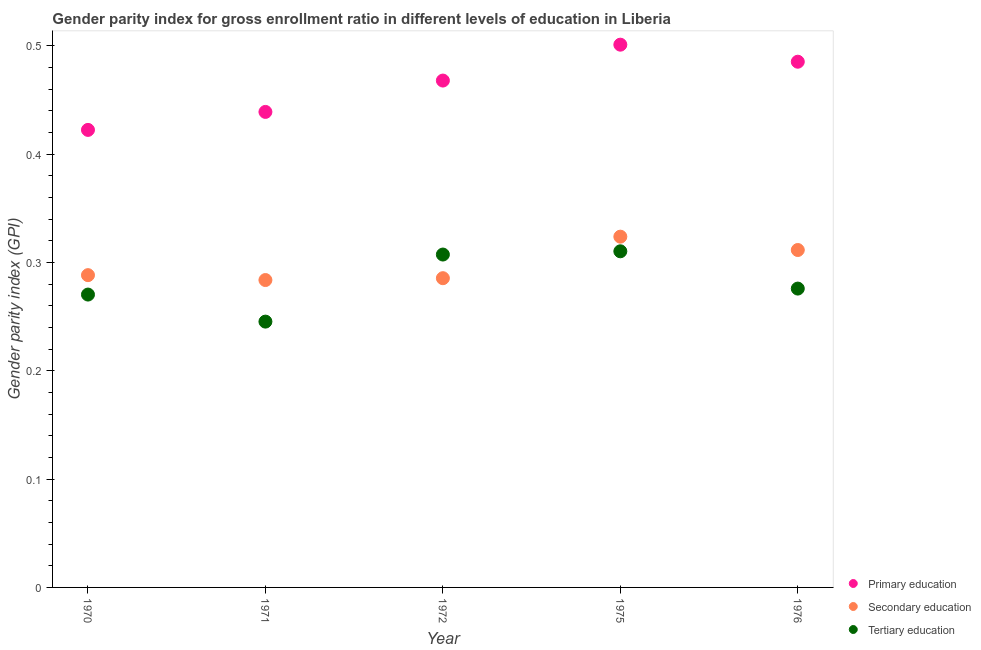How many different coloured dotlines are there?
Give a very brief answer. 3. What is the gender parity index in secondary education in 1971?
Your answer should be compact. 0.28. Across all years, what is the maximum gender parity index in tertiary education?
Make the answer very short. 0.31. Across all years, what is the minimum gender parity index in tertiary education?
Your response must be concise. 0.25. In which year was the gender parity index in primary education maximum?
Offer a terse response. 1975. What is the total gender parity index in secondary education in the graph?
Your answer should be very brief. 1.49. What is the difference between the gender parity index in primary education in 1970 and that in 1972?
Ensure brevity in your answer.  -0.05. What is the difference between the gender parity index in primary education in 1976 and the gender parity index in secondary education in 1970?
Ensure brevity in your answer.  0.2. What is the average gender parity index in primary education per year?
Your answer should be compact. 0.46. In the year 1976, what is the difference between the gender parity index in primary education and gender parity index in tertiary education?
Provide a succinct answer. 0.21. What is the ratio of the gender parity index in secondary education in 1971 to that in 1976?
Keep it short and to the point. 0.91. Is the gender parity index in tertiary education in 1972 less than that in 1976?
Your response must be concise. No. What is the difference between the highest and the second highest gender parity index in tertiary education?
Make the answer very short. 0. What is the difference between the highest and the lowest gender parity index in primary education?
Make the answer very short. 0.08. Is the sum of the gender parity index in tertiary education in 1970 and 1972 greater than the maximum gender parity index in secondary education across all years?
Offer a very short reply. Yes. Is it the case that in every year, the sum of the gender parity index in primary education and gender parity index in secondary education is greater than the gender parity index in tertiary education?
Your answer should be very brief. Yes. How many dotlines are there?
Give a very brief answer. 3. What is the difference between two consecutive major ticks on the Y-axis?
Offer a terse response. 0.1. How are the legend labels stacked?
Give a very brief answer. Vertical. What is the title of the graph?
Offer a terse response. Gender parity index for gross enrollment ratio in different levels of education in Liberia. Does "Machinery" appear as one of the legend labels in the graph?
Offer a terse response. No. What is the label or title of the X-axis?
Provide a short and direct response. Year. What is the label or title of the Y-axis?
Your answer should be very brief. Gender parity index (GPI). What is the Gender parity index (GPI) of Primary education in 1970?
Keep it short and to the point. 0.42. What is the Gender parity index (GPI) of Secondary education in 1970?
Your answer should be compact. 0.29. What is the Gender parity index (GPI) in Tertiary education in 1970?
Ensure brevity in your answer.  0.27. What is the Gender parity index (GPI) of Primary education in 1971?
Your answer should be very brief. 0.44. What is the Gender parity index (GPI) of Secondary education in 1971?
Your response must be concise. 0.28. What is the Gender parity index (GPI) of Tertiary education in 1971?
Ensure brevity in your answer.  0.25. What is the Gender parity index (GPI) of Primary education in 1972?
Your response must be concise. 0.47. What is the Gender parity index (GPI) in Secondary education in 1972?
Your answer should be compact. 0.29. What is the Gender parity index (GPI) of Tertiary education in 1972?
Provide a short and direct response. 0.31. What is the Gender parity index (GPI) in Primary education in 1975?
Offer a very short reply. 0.5. What is the Gender parity index (GPI) in Secondary education in 1975?
Provide a short and direct response. 0.32. What is the Gender parity index (GPI) in Tertiary education in 1975?
Your answer should be compact. 0.31. What is the Gender parity index (GPI) of Primary education in 1976?
Make the answer very short. 0.49. What is the Gender parity index (GPI) in Secondary education in 1976?
Provide a short and direct response. 0.31. What is the Gender parity index (GPI) of Tertiary education in 1976?
Ensure brevity in your answer.  0.28. Across all years, what is the maximum Gender parity index (GPI) in Primary education?
Keep it short and to the point. 0.5. Across all years, what is the maximum Gender parity index (GPI) of Secondary education?
Offer a terse response. 0.32. Across all years, what is the maximum Gender parity index (GPI) of Tertiary education?
Make the answer very short. 0.31. Across all years, what is the minimum Gender parity index (GPI) in Primary education?
Ensure brevity in your answer.  0.42. Across all years, what is the minimum Gender parity index (GPI) of Secondary education?
Provide a short and direct response. 0.28. Across all years, what is the minimum Gender parity index (GPI) in Tertiary education?
Keep it short and to the point. 0.25. What is the total Gender parity index (GPI) of Primary education in the graph?
Provide a short and direct response. 2.32. What is the total Gender parity index (GPI) of Secondary education in the graph?
Your answer should be very brief. 1.49. What is the total Gender parity index (GPI) of Tertiary education in the graph?
Make the answer very short. 1.41. What is the difference between the Gender parity index (GPI) of Primary education in 1970 and that in 1971?
Offer a terse response. -0.02. What is the difference between the Gender parity index (GPI) of Secondary education in 1970 and that in 1971?
Offer a terse response. 0. What is the difference between the Gender parity index (GPI) in Tertiary education in 1970 and that in 1971?
Offer a very short reply. 0.03. What is the difference between the Gender parity index (GPI) of Primary education in 1970 and that in 1972?
Offer a terse response. -0.05. What is the difference between the Gender parity index (GPI) in Secondary education in 1970 and that in 1972?
Provide a succinct answer. 0. What is the difference between the Gender parity index (GPI) in Tertiary education in 1970 and that in 1972?
Ensure brevity in your answer.  -0.04. What is the difference between the Gender parity index (GPI) in Primary education in 1970 and that in 1975?
Provide a succinct answer. -0.08. What is the difference between the Gender parity index (GPI) of Secondary education in 1970 and that in 1975?
Give a very brief answer. -0.04. What is the difference between the Gender parity index (GPI) in Tertiary education in 1970 and that in 1975?
Offer a terse response. -0.04. What is the difference between the Gender parity index (GPI) in Primary education in 1970 and that in 1976?
Your answer should be very brief. -0.06. What is the difference between the Gender parity index (GPI) in Secondary education in 1970 and that in 1976?
Offer a terse response. -0.02. What is the difference between the Gender parity index (GPI) of Tertiary education in 1970 and that in 1976?
Keep it short and to the point. -0.01. What is the difference between the Gender parity index (GPI) in Primary education in 1971 and that in 1972?
Keep it short and to the point. -0.03. What is the difference between the Gender parity index (GPI) of Secondary education in 1971 and that in 1972?
Ensure brevity in your answer.  -0. What is the difference between the Gender parity index (GPI) of Tertiary education in 1971 and that in 1972?
Offer a very short reply. -0.06. What is the difference between the Gender parity index (GPI) in Primary education in 1971 and that in 1975?
Your answer should be very brief. -0.06. What is the difference between the Gender parity index (GPI) in Secondary education in 1971 and that in 1975?
Your answer should be compact. -0.04. What is the difference between the Gender parity index (GPI) of Tertiary education in 1971 and that in 1975?
Keep it short and to the point. -0.06. What is the difference between the Gender parity index (GPI) of Primary education in 1971 and that in 1976?
Offer a terse response. -0.05. What is the difference between the Gender parity index (GPI) of Secondary education in 1971 and that in 1976?
Ensure brevity in your answer.  -0.03. What is the difference between the Gender parity index (GPI) in Tertiary education in 1971 and that in 1976?
Provide a short and direct response. -0.03. What is the difference between the Gender parity index (GPI) in Primary education in 1972 and that in 1975?
Your answer should be very brief. -0.03. What is the difference between the Gender parity index (GPI) in Secondary education in 1972 and that in 1975?
Offer a very short reply. -0.04. What is the difference between the Gender parity index (GPI) of Tertiary education in 1972 and that in 1975?
Your answer should be compact. -0. What is the difference between the Gender parity index (GPI) in Primary education in 1972 and that in 1976?
Offer a terse response. -0.02. What is the difference between the Gender parity index (GPI) in Secondary education in 1972 and that in 1976?
Offer a terse response. -0.03. What is the difference between the Gender parity index (GPI) of Tertiary education in 1972 and that in 1976?
Give a very brief answer. 0.03. What is the difference between the Gender parity index (GPI) in Primary education in 1975 and that in 1976?
Offer a terse response. 0.02. What is the difference between the Gender parity index (GPI) in Secondary education in 1975 and that in 1976?
Your answer should be very brief. 0.01. What is the difference between the Gender parity index (GPI) in Tertiary education in 1975 and that in 1976?
Your answer should be very brief. 0.03. What is the difference between the Gender parity index (GPI) of Primary education in 1970 and the Gender parity index (GPI) of Secondary education in 1971?
Your answer should be compact. 0.14. What is the difference between the Gender parity index (GPI) in Primary education in 1970 and the Gender parity index (GPI) in Tertiary education in 1971?
Your answer should be very brief. 0.18. What is the difference between the Gender parity index (GPI) in Secondary education in 1970 and the Gender parity index (GPI) in Tertiary education in 1971?
Offer a terse response. 0.04. What is the difference between the Gender parity index (GPI) of Primary education in 1970 and the Gender parity index (GPI) of Secondary education in 1972?
Keep it short and to the point. 0.14. What is the difference between the Gender parity index (GPI) in Primary education in 1970 and the Gender parity index (GPI) in Tertiary education in 1972?
Keep it short and to the point. 0.12. What is the difference between the Gender parity index (GPI) in Secondary education in 1970 and the Gender parity index (GPI) in Tertiary education in 1972?
Ensure brevity in your answer.  -0.02. What is the difference between the Gender parity index (GPI) in Primary education in 1970 and the Gender parity index (GPI) in Secondary education in 1975?
Keep it short and to the point. 0.1. What is the difference between the Gender parity index (GPI) in Primary education in 1970 and the Gender parity index (GPI) in Tertiary education in 1975?
Provide a succinct answer. 0.11. What is the difference between the Gender parity index (GPI) of Secondary education in 1970 and the Gender parity index (GPI) of Tertiary education in 1975?
Offer a terse response. -0.02. What is the difference between the Gender parity index (GPI) of Primary education in 1970 and the Gender parity index (GPI) of Secondary education in 1976?
Offer a very short reply. 0.11. What is the difference between the Gender parity index (GPI) of Primary education in 1970 and the Gender parity index (GPI) of Tertiary education in 1976?
Ensure brevity in your answer.  0.15. What is the difference between the Gender parity index (GPI) in Secondary education in 1970 and the Gender parity index (GPI) in Tertiary education in 1976?
Keep it short and to the point. 0.01. What is the difference between the Gender parity index (GPI) of Primary education in 1971 and the Gender parity index (GPI) of Secondary education in 1972?
Offer a very short reply. 0.15. What is the difference between the Gender parity index (GPI) of Primary education in 1971 and the Gender parity index (GPI) of Tertiary education in 1972?
Offer a very short reply. 0.13. What is the difference between the Gender parity index (GPI) in Secondary education in 1971 and the Gender parity index (GPI) in Tertiary education in 1972?
Make the answer very short. -0.02. What is the difference between the Gender parity index (GPI) in Primary education in 1971 and the Gender parity index (GPI) in Secondary education in 1975?
Offer a terse response. 0.12. What is the difference between the Gender parity index (GPI) of Primary education in 1971 and the Gender parity index (GPI) of Tertiary education in 1975?
Provide a short and direct response. 0.13. What is the difference between the Gender parity index (GPI) in Secondary education in 1971 and the Gender parity index (GPI) in Tertiary education in 1975?
Provide a short and direct response. -0.03. What is the difference between the Gender parity index (GPI) of Primary education in 1971 and the Gender parity index (GPI) of Secondary education in 1976?
Your answer should be compact. 0.13. What is the difference between the Gender parity index (GPI) of Primary education in 1971 and the Gender parity index (GPI) of Tertiary education in 1976?
Offer a terse response. 0.16. What is the difference between the Gender parity index (GPI) of Secondary education in 1971 and the Gender parity index (GPI) of Tertiary education in 1976?
Offer a very short reply. 0.01. What is the difference between the Gender parity index (GPI) of Primary education in 1972 and the Gender parity index (GPI) of Secondary education in 1975?
Keep it short and to the point. 0.14. What is the difference between the Gender parity index (GPI) in Primary education in 1972 and the Gender parity index (GPI) in Tertiary education in 1975?
Your response must be concise. 0.16. What is the difference between the Gender parity index (GPI) of Secondary education in 1972 and the Gender parity index (GPI) of Tertiary education in 1975?
Offer a terse response. -0.02. What is the difference between the Gender parity index (GPI) in Primary education in 1972 and the Gender parity index (GPI) in Secondary education in 1976?
Offer a terse response. 0.16. What is the difference between the Gender parity index (GPI) in Primary education in 1972 and the Gender parity index (GPI) in Tertiary education in 1976?
Offer a very short reply. 0.19. What is the difference between the Gender parity index (GPI) in Secondary education in 1972 and the Gender parity index (GPI) in Tertiary education in 1976?
Keep it short and to the point. 0.01. What is the difference between the Gender parity index (GPI) in Primary education in 1975 and the Gender parity index (GPI) in Secondary education in 1976?
Offer a terse response. 0.19. What is the difference between the Gender parity index (GPI) in Primary education in 1975 and the Gender parity index (GPI) in Tertiary education in 1976?
Provide a succinct answer. 0.23. What is the difference between the Gender parity index (GPI) of Secondary education in 1975 and the Gender parity index (GPI) of Tertiary education in 1976?
Provide a short and direct response. 0.05. What is the average Gender parity index (GPI) of Primary education per year?
Provide a short and direct response. 0.46. What is the average Gender parity index (GPI) in Secondary education per year?
Make the answer very short. 0.3. What is the average Gender parity index (GPI) in Tertiary education per year?
Make the answer very short. 0.28. In the year 1970, what is the difference between the Gender parity index (GPI) in Primary education and Gender parity index (GPI) in Secondary education?
Provide a short and direct response. 0.13. In the year 1970, what is the difference between the Gender parity index (GPI) of Primary education and Gender parity index (GPI) of Tertiary education?
Ensure brevity in your answer.  0.15. In the year 1970, what is the difference between the Gender parity index (GPI) in Secondary education and Gender parity index (GPI) in Tertiary education?
Provide a succinct answer. 0.02. In the year 1971, what is the difference between the Gender parity index (GPI) of Primary education and Gender parity index (GPI) of Secondary education?
Give a very brief answer. 0.16. In the year 1971, what is the difference between the Gender parity index (GPI) of Primary education and Gender parity index (GPI) of Tertiary education?
Keep it short and to the point. 0.19. In the year 1971, what is the difference between the Gender parity index (GPI) in Secondary education and Gender parity index (GPI) in Tertiary education?
Provide a succinct answer. 0.04. In the year 1972, what is the difference between the Gender parity index (GPI) of Primary education and Gender parity index (GPI) of Secondary education?
Ensure brevity in your answer.  0.18. In the year 1972, what is the difference between the Gender parity index (GPI) of Primary education and Gender parity index (GPI) of Tertiary education?
Give a very brief answer. 0.16. In the year 1972, what is the difference between the Gender parity index (GPI) in Secondary education and Gender parity index (GPI) in Tertiary education?
Keep it short and to the point. -0.02. In the year 1975, what is the difference between the Gender parity index (GPI) of Primary education and Gender parity index (GPI) of Secondary education?
Provide a short and direct response. 0.18. In the year 1975, what is the difference between the Gender parity index (GPI) in Primary education and Gender parity index (GPI) in Tertiary education?
Your response must be concise. 0.19. In the year 1975, what is the difference between the Gender parity index (GPI) of Secondary education and Gender parity index (GPI) of Tertiary education?
Keep it short and to the point. 0.01. In the year 1976, what is the difference between the Gender parity index (GPI) in Primary education and Gender parity index (GPI) in Secondary education?
Offer a terse response. 0.17. In the year 1976, what is the difference between the Gender parity index (GPI) of Primary education and Gender parity index (GPI) of Tertiary education?
Offer a terse response. 0.21. In the year 1976, what is the difference between the Gender parity index (GPI) of Secondary education and Gender parity index (GPI) of Tertiary education?
Provide a succinct answer. 0.04. What is the ratio of the Gender parity index (GPI) in Primary education in 1970 to that in 1971?
Make the answer very short. 0.96. What is the ratio of the Gender parity index (GPI) in Secondary education in 1970 to that in 1971?
Offer a very short reply. 1.02. What is the ratio of the Gender parity index (GPI) of Tertiary education in 1970 to that in 1971?
Provide a short and direct response. 1.1. What is the ratio of the Gender parity index (GPI) in Primary education in 1970 to that in 1972?
Your answer should be very brief. 0.9. What is the ratio of the Gender parity index (GPI) in Secondary education in 1970 to that in 1972?
Give a very brief answer. 1.01. What is the ratio of the Gender parity index (GPI) in Tertiary education in 1970 to that in 1972?
Provide a succinct answer. 0.88. What is the ratio of the Gender parity index (GPI) of Primary education in 1970 to that in 1975?
Give a very brief answer. 0.84. What is the ratio of the Gender parity index (GPI) of Secondary education in 1970 to that in 1975?
Offer a very short reply. 0.89. What is the ratio of the Gender parity index (GPI) in Tertiary education in 1970 to that in 1975?
Ensure brevity in your answer.  0.87. What is the ratio of the Gender parity index (GPI) in Primary education in 1970 to that in 1976?
Give a very brief answer. 0.87. What is the ratio of the Gender parity index (GPI) of Secondary education in 1970 to that in 1976?
Keep it short and to the point. 0.93. What is the ratio of the Gender parity index (GPI) in Tertiary education in 1970 to that in 1976?
Provide a short and direct response. 0.98. What is the ratio of the Gender parity index (GPI) in Primary education in 1971 to that in 1972?
Offer a very short reply. 0.94. What is the ratio of the Gender parity index (GPI) in Tertiary education in 1971 to that in 1972?
Provide a succinct answer. 0.8. What is the ratio of the Gender parity index (GPI) in Primary education in 1971 to that in 1975?
Ensure brevity in your answer.  0.88. What is the ratio of the Gender parity index (GPI) of Secondary education in 1971 to that in 1975?
Offer a very short reply. 0.88. What is the ratio of the Gender parity index (GPI) of Tertiary education in 1971 to that in 1975?
Offer a terse response. 0.79. What is the ratio of the Gender parity index (GPI) of Primary education in 1971 to that in 1976?
Provide a short and direct response. 0.9. What is the ratio of the Gender parity index (GPI) in Secondary education in 1971 to that in 1976?
Your answer should be compact. 0.91. What is the ratio of the Gender parity index (GPI) in Tertiary education in 1971 to that in 1976?
Ensure brevity in your answer.  0.89. What is the ratio of the Gender parity index (GPI) in Primary education in 1972 to that in 1975?
Make the answer very short. 0.93. What is the ratio of the Gender parity index (GPI) of Secondary education in 1972 to that in 1975?
Provide a short and direct response. 0.88. What is the ratio of the Gender parity index (GPI) of Tertiary education in 1972 to that in 1975?
Give a very brief answer. 0.99. What is the ratio of the Gender parity index (GPI) of Primary education in 1972 to that in 1976?
Offer a very short reply. 0.96. What is the ratio of the Gender parity index (GPI) in Secondary education in 1972 to that in 1976?
Ensure brevity in your answer.  0.92. What is the ratio of the Gender parity index (GPI) of Tertiary education in 1972 to that in 1976?
Give a very brief answer. 1.11. What is the ratio of the Gender parity index (GPI) of Primary education in 1975 to that in 1976?
Your answer should be very brief. 1.03. What is the ratio of the Gender parity index (GPI) in Secondary education in 1975 to that in 1976?
Give a very brief answer. 1.04. What is the ratio of the Gender parity index (GPI) in Tertiary education in 1975 to that in 1976?
Your answer should be compact. 1.12. What is the difference between the highest and the second highest Gender parity index (GPI) of Primary education?
Offer a terse response. 0.02. What is the difference between the highest and the second highest Gender parity index (GPI) of Secondary education?
Make the answer very short. 0.01. What is the difference between the highest and the second highest Gender parity index (GPI) in Tertiary education?
Offer a terse response. 0. What is the difference between the highest and the lowest Gender parity index (GPI) in Primary education?
Ensure brevity in your answer.  0.08. What is the difference between the highest and the lowest Gender parity index (GPI) of Secondary education?
Your answer should be very brief. 0.04. What is the difference between the highest and the lowest Gender parity index (GPI) of Tertiary education?
Your answer should be compact. 0.06. 